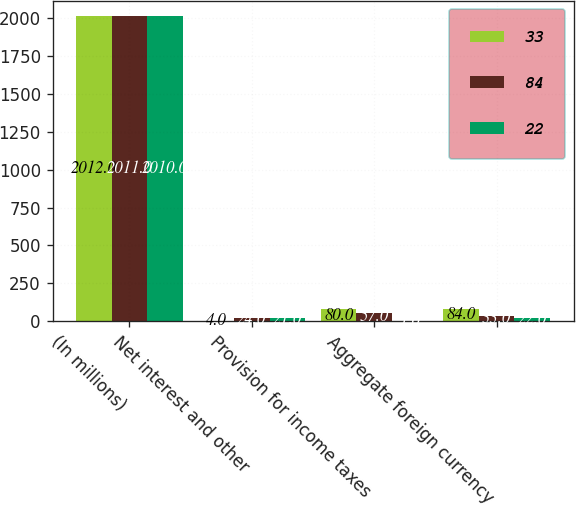Convert chart. <chart><loc_0><loc_0><loc_500><loc_500><stacked_bar_chart><ecel><fcel>(In millions)<fcel>Net interest and other<fcel>Provision for income taxes<fcel>Aggregate foreign currency<nl><fcel>33<fcel>2012<fcel>4<fcel>80<fcel>84<nl><fcel>84<fcel>2011<fcel>24<fcel>57<fcel>33<nl><fcel>22<fcel>2010<fcel>21<fcel>1<fcel>22<nl></chart> 